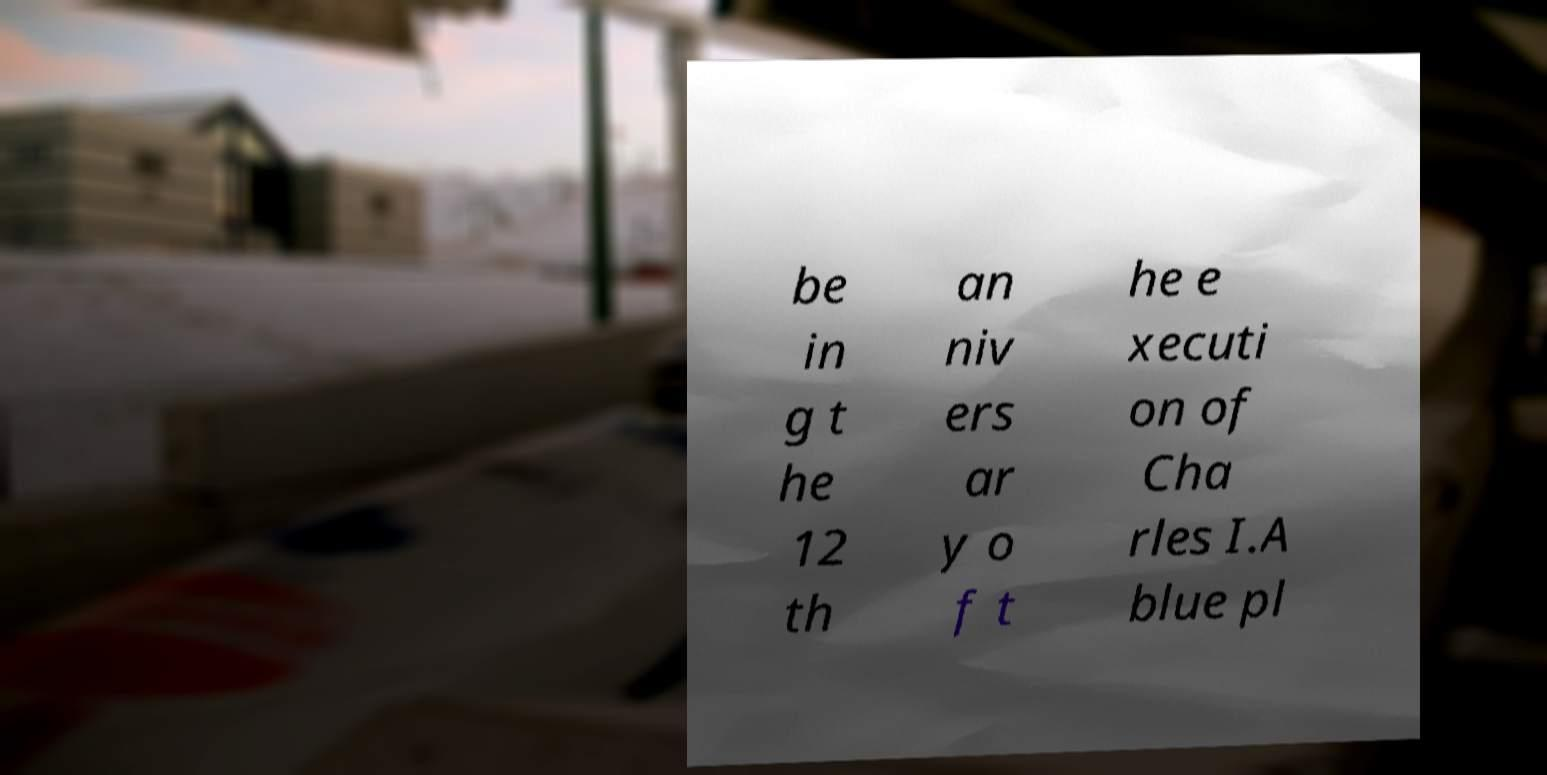There's text embedded in this image that I need extracted. Can you transcribe it verbatim? be in g t he 12 th an niv ers ar y o f t he e xecuti on of Cha rles I.A blue pl 